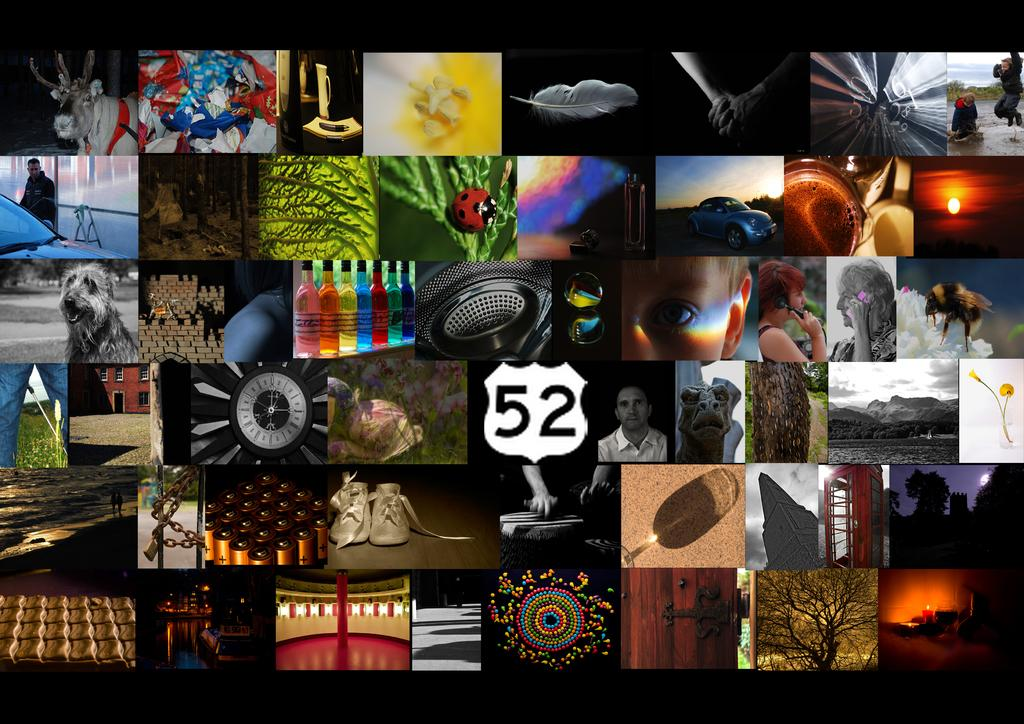<image>
Write a terse but informative summary of the picture. A collage of photographs including one of a highway 52 sign. 